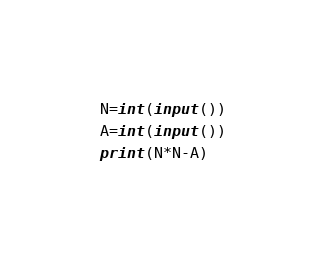<code> <loc_0><loc_0><loc_500><loc_500><_Python_>N=int(input())
A=int(input())
print(N*N-A)</code> 